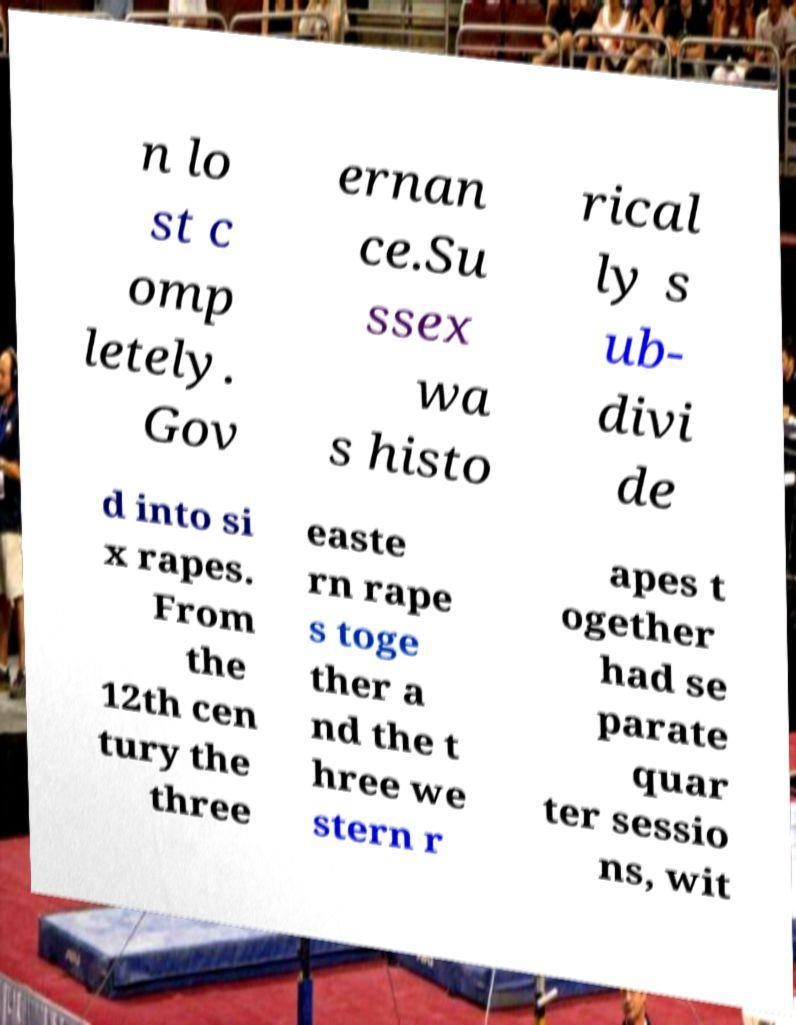There's text embedded in this image that I need extracted. Can you transcribe it verbatim? n lo st c omp letely. Gov ernan ce.Su ssex wa s histo rical ly s ub- divi de d into si x rapes. From the 12th cen tury the three easte rn rape s toge ther a nd the t hree we stern r apes t ogether had se parate quar ter sessio ns, wit 